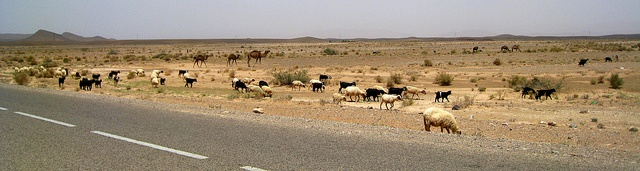Describe the objects in this image and their specific colors. I can see sheep in darkgray, tan, gray, and olive tones, sheep in darkgray, khaki, maroon, and tan tones, sheep in darkgray, khaki, lightyellow, brown, and maroon tones, sheep in darkgray, tan, maroon, and beige tones, and sheep in darkgray, tan, and olive tones in this image. 